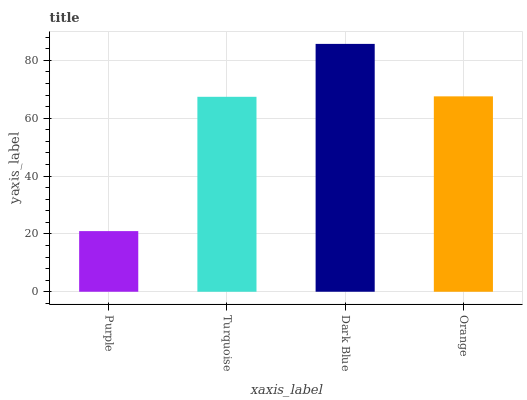Is Purple the minimum?
Answer yes or no. Yes. Is Dark Blue the maximum?
Answer yes or no. Yes. Is Turquoise the minimum?
Answer yes or no. No. Is Turquoise the maximum?
Answer yes or no. No. Is Turquoise greater than Purple?
Answer yes or no. Yes. Is Purple less than Turquoise?
Answer yes or no. Yes. Is Purple greater than Turquoise?
Answer yes or no. No. Is Turquoise less than Purple?
Answer yes or no. No. Is Orange the high median?
Answer yes or no. Yes. Is Turquoise the low median?
Answer yes or no. Yes. Is Turquoise the high median?
Answer yes or no. No. Is Purple the low median?
Answer yes or no. No. 